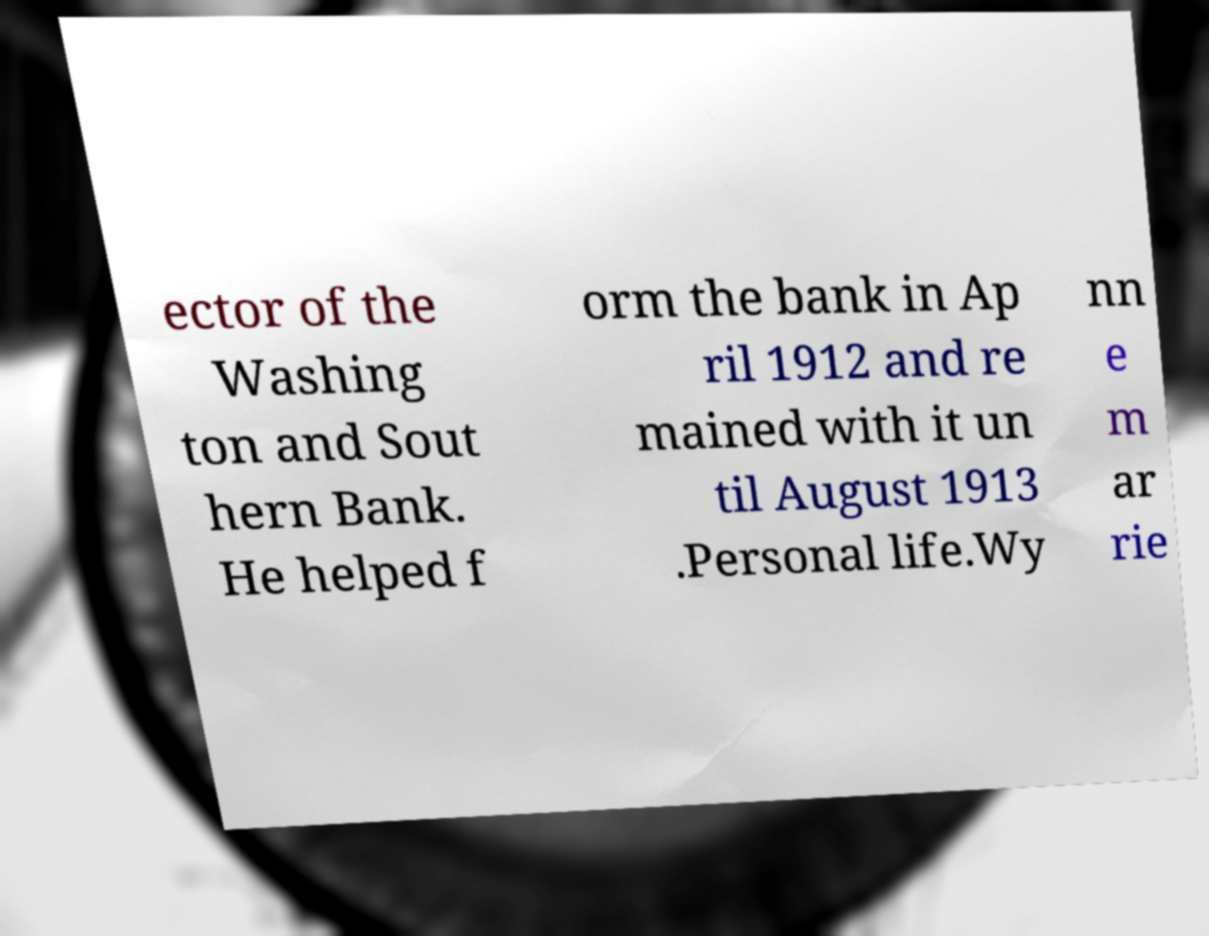For documentation purposes, I need the text within this image transcribed. Could you provide that? ector of the Washing ton and Sout hern Bank. He helped f orm the bank in Ap ril 1912 and re mained with it un til August 1913 .Personal life.Wy nn e m ar rie 